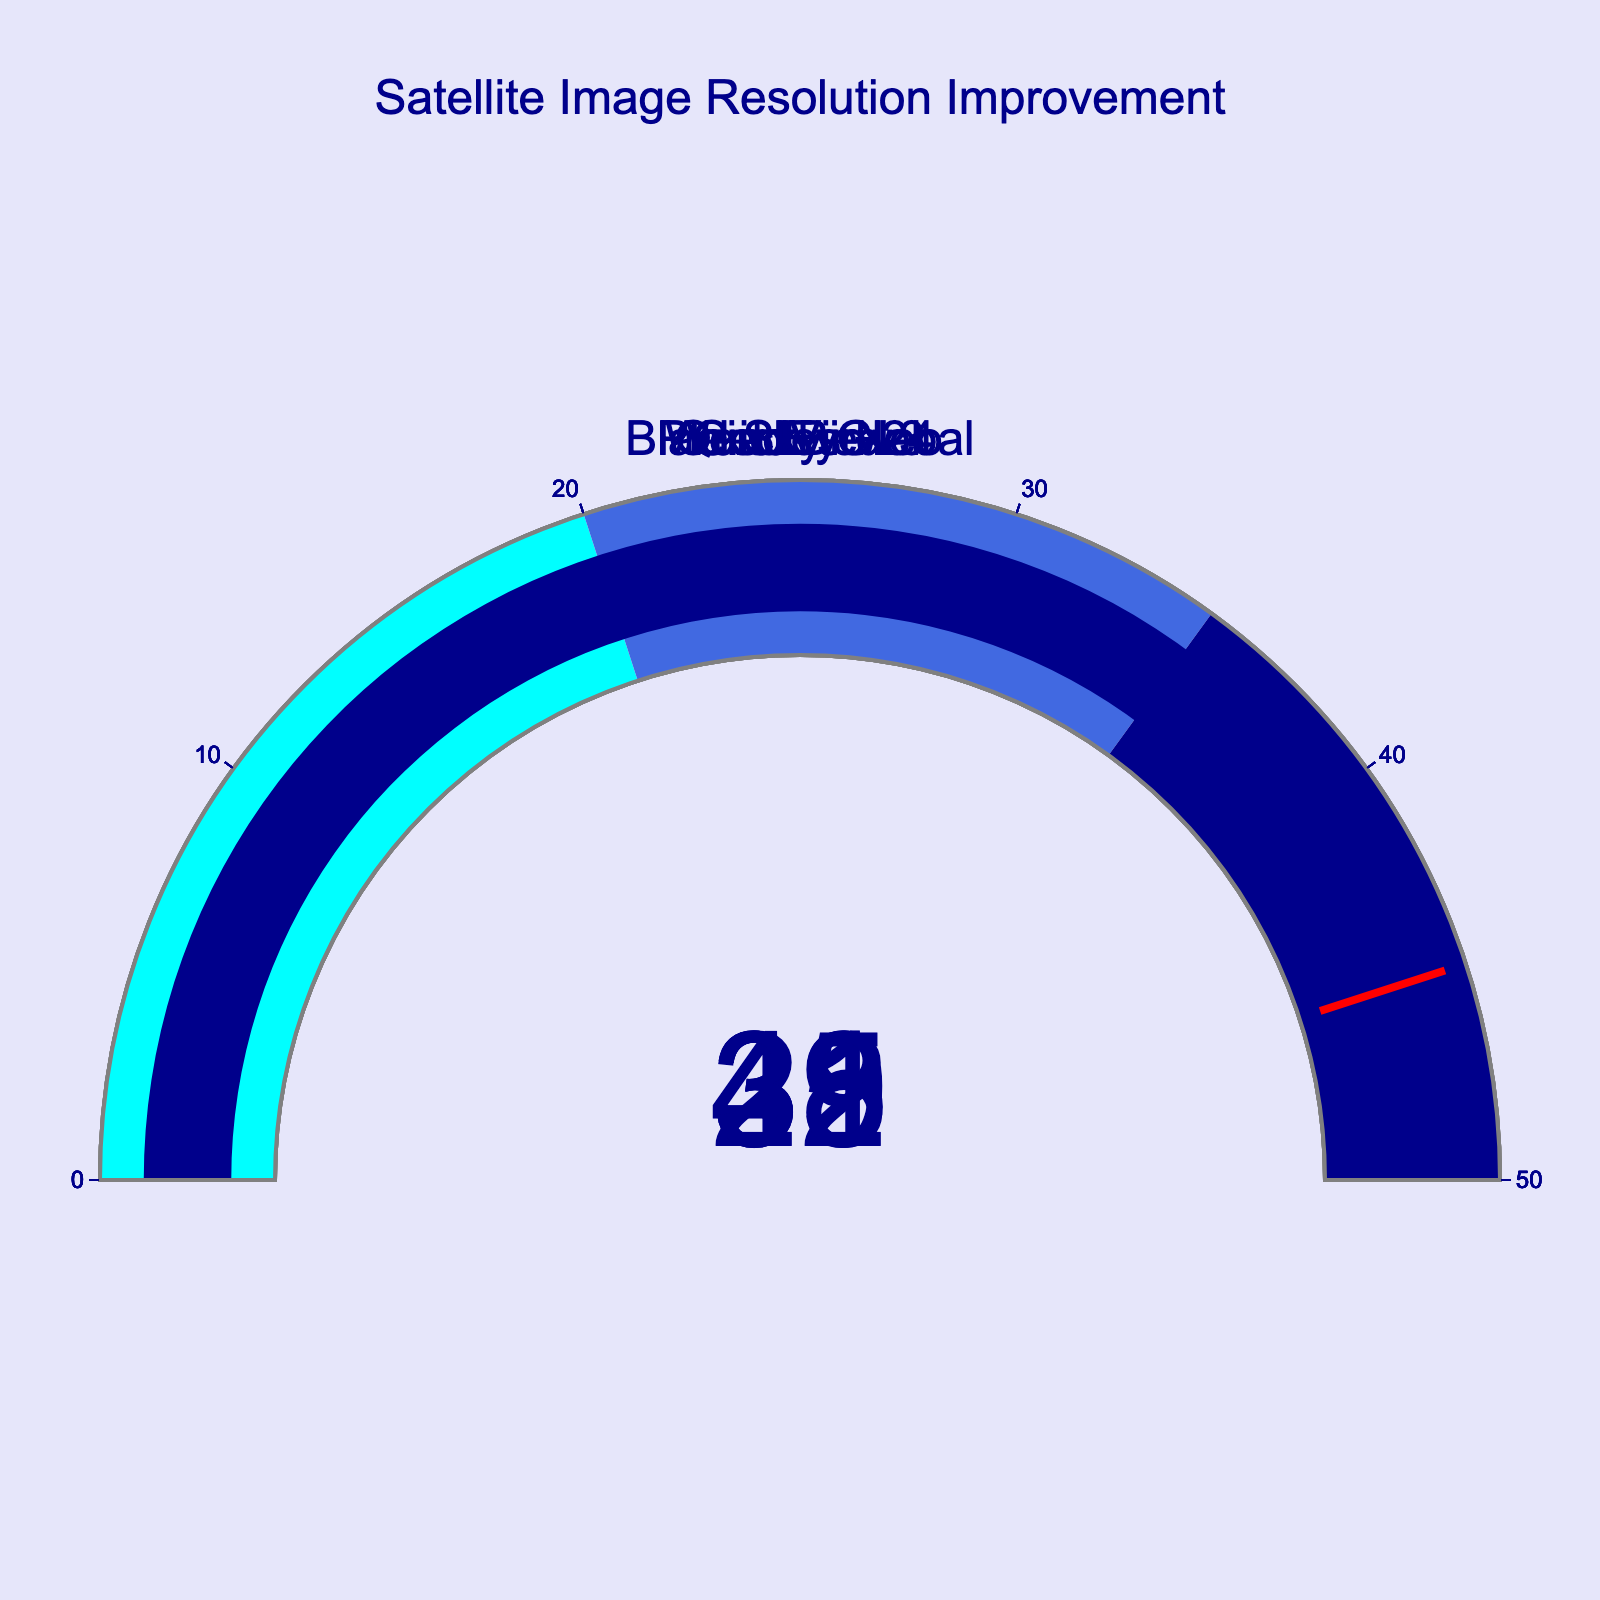What is the title of the figure? The title is placed at the top center of the figure and typically describes the main content of the chart.
Answer: Satellite Image Resolution Improvement How many satellites are represented in the figure? There is a distinct gauge chart for each satellite, and by counting them, we see that there are five separate gauges.
Answer: 5 Which satellite has the highest resolution improvement percentage? By examining the values displayed on each gauge, we see that GeoEye-2 has the highest value at 42%.
Answer: GeoEye-2 What's the difference in resolution improvement between WorldView-4 and Pleiades Neo? WorldView-4 has a resolution improvement of 35%, while Pleiades Neo has 28%. The difference is calculated as 35 - 28 = 7%.
Answer: 7% Which satellites have resolution improvement percentages above 30%? By identifying which gauges display values greater than 30%, we find that WorldView-4, GeoEye-2, QuickBird-3, and BlackSky Global meet this criterion.
Answer: WorldView-4, GeoEye-2, QuickBird-3, BlackSky Global What is the average resolution improvement percentage across all satellites? Summing up the resolution improvements (35, 42, 28, 31, 39) gives 175. Dividing by the number of satellites (5) results in an average of 35%.
Answer: 35% How many satellites fall into the range of 35-50% improvement? Observing the gauge colors, the range from 35 to 50% results in the dark blue region. WorldView-4, GeoEye-2, and BlackSky Global fall into this range.
Answer: 3 Which satellite's resolution improvement is closest to the threshold of 45%? By visually inspecting each gauge’s value, GeoEye-2, which has a resolution improvement of 42%, is closest to 45%.
Answer: GeoEye-2 Is QuickBird-3's resolution improvement higher or lower than BlackSky Global's? By comparing the values on their respective gauges, QuickBird-3 improves by 31%, while BlackSky Global improves by 39%.
Answer: Lower 